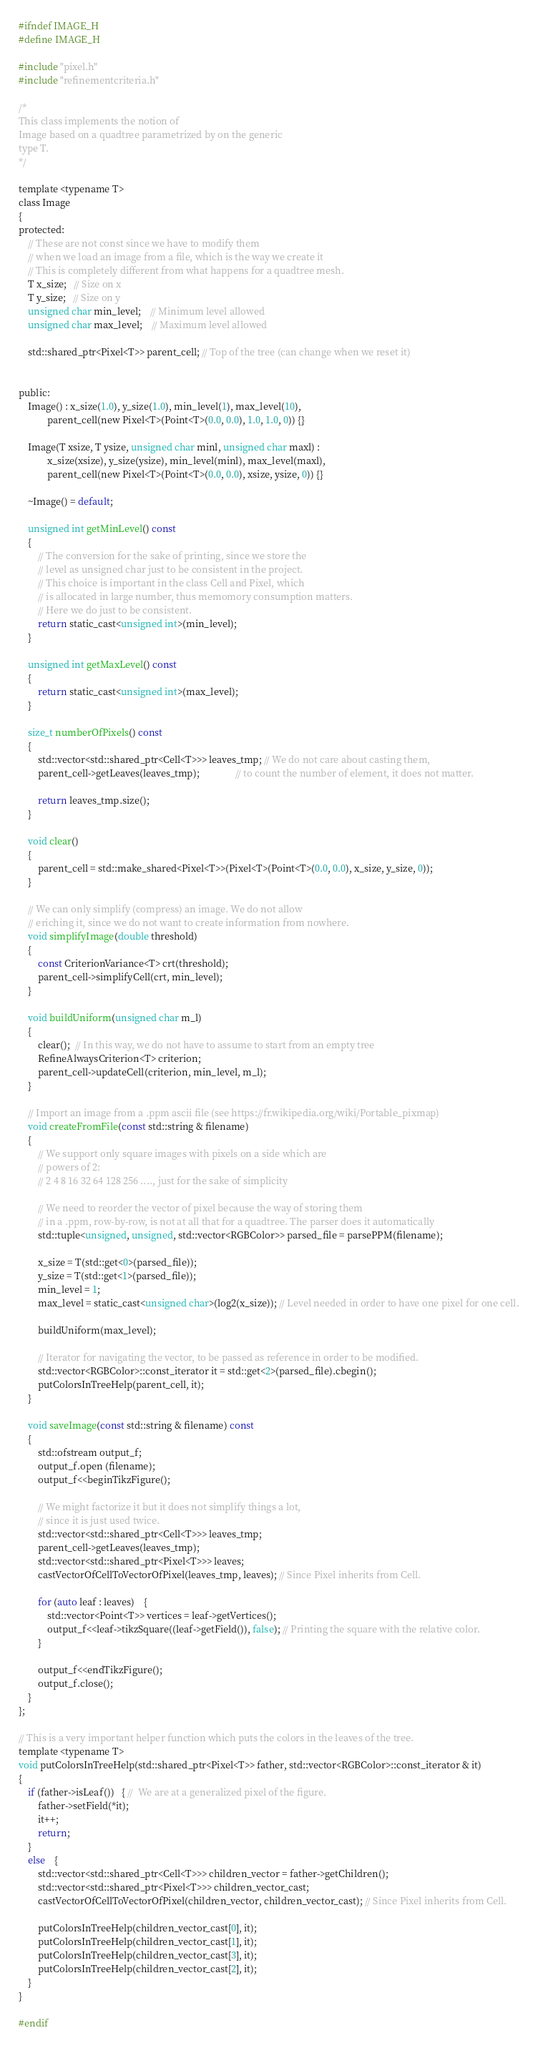Convert code to text. <code><loc_0><loc_0><loc_500><loc_500><_C_>#ifndef IMAGE_H
#define IMAGE_H

#include "pixel.h"
#include "refinementcriteria.h"

/*
This class implements the notion of 
Image based on a quadtree parametrized by on the generic 
type T.
*/

template <typename T>
class Image
{
protected:
    // These are not const since we have to modify them
    // when we load an image from a file, which is the way we create it
    // This is completely different from what happens for a quadtree mesh.
    T x_size;   // Size on x
    T y_size;   // Size on y
    unsigned char min_level;    // Minimum level allowed  
    unsigned char max_level;    // Maximum level allowed
    
    std::shared_ptr<Pixel<T>> parent_cell; // Top of the tree (can change when we reset it)


public:
    Image() : x_size(1.0), y_size(1.0), min_level(1), max_level(10), 
            parent_cell(new Pixel<T>(Point<T>(0.0, 0.0), 1.0, 1.0, 0)) {}

    Image(T xsize, T ysize, unsigned char minl, unsigned char maxl) : 
            x_size(xsize), y_size(ysize), min_level(minl), max_level(maxl), 
            parent_cell(new Pixel<T>(Point<T>(0.0, 0.0), xsize, ysize, 0)) {}

    ~Image() = default;

    unsigned int getMinLevel() const
    {
        // The conversion for the sake of printing, since we store the
        // level as unsigned char just to be consistent in the project.
        // This choice is important in the class Cell and Pixel, which
        // is allocated in large number, thus memomory consumption matters.
        // Here we do just to be consistent.
        return static_cast<unsigned int>(min_level);
    }

    unsigned int getMaxLevel() const
    {
        return static_cast<unsigned int>(max_level);
    }

    size_t numberOfPixels() const
    {
        std::vector<std::shared_ptr<Cell<T>>> leaves_tmp; // We do not care about casting them, 
        parent_cell->getLeaves(leaves_tmp);               // to count the number of element, it does not matter.

        return leaves_tmp.size();
    }

    void clear()
    {
        parent_cell = std::make_shared<Pixel<T>>(Pixel<T>(Point<T>(0.0, 0.0), x_size, y_size, 0));
    }

    // We can only simplify (compress) an image. We do not allow
    // eriching it, since we do not want to create information from nowhere.
    void simplifyImage(double threshold)
    {
        const CriterionVariance<T> crt(threshold);
        parent_cell->simplifyCell(crt, min_level);
    }

    void buildUniform(unsigned char m_l) 
    {
        clear();  // In this way, we do not have to assume to start from an empty tree
        RefineAlwaysCriterion<T> criterion;
        parent_cell->updateCell(criterion, min_level, m_l);
    }

    // Import an image from a .ppm ascii file (see https://fr.wikipedia.org/wiki/Portable_pixmap)
    void createFromFile(const std::string & filename)
    {
        // We support only square images with pixels on a side which are
        // powers of 2:
        // 2 4 8 16 32 64 128 256 ...., just for the sake of simplicity

        // We need to reorder the vector of pixel because the way of storing them
        // in a .ppm, row-by-row, is not at all that for a quadtree. The parser does it automatically
        std::tuple<unsigned, unsigned, std::vector<RGBColor>> parsed_file = parsePPM(filename);

        x_size = T(std::get<0>(parsed_file)); 
        y_size = T(std::get<1>(parsed_file)); 
        min_level = 1;
        max_level = static_cast<unsigned char>(log2(x_size)); // Level needed in order to have one pixel for one cell.

        buildUniform(max_level);

        // Iterator for navigating the vector, to be passed as reference in order to be modified.
        std::vector<RGBColor>::const_iterator it = std::get<2>(parsed_file).cbegin();
        putColorsInTreeHelp(parent_cell, it);
    }

    void saveImage(const std::string & filename) const
    {
        std::ofstream output_f;
        output_f.open (filename);
        output_f<<beginTikzFigure();

        // We might factorize it but it does not simplify things a lot,
        // since it is just used twice.
        std::vector<std::shared_ptr<Cell<T>>> leaves_tmp; 
        parent_cell->getLeaves(leaves_tmp);
        std::vector<std::shared_ptr<Pixel<T>>> leaves;
        castVectorOfCellToVectorOfPixel(leaves_tmp, leaves); // Since Pixel inherits from Cell.

        for (auto leaf : leaves)    {
            std::vector<Point<T>> vertices = leaf->getVertices();
            output_f<<leaf->tikzSquare((leaf->getField()), false); // Printing the square with the relative color.
        }

        output_f<<endTikzFigure();
        output_f.close();
    }
};

// This is a very important helper function which puts the colors in the leaves of the tree.
template <typename T>
void putColorsInTreeHelp(std::shared_ptr<Pixel<T>> father, std::vector<RGBColor>::const_iterator & it)
{
    if (father->isLeaf())   { //  We are at a generalized pixel of the figure.
        father->setField(*it);
        it++;
        return;
    }
    else    {
        std::vector<std::shared_ptr<Cell<T>>> children_vector = father->getChildren();
        std::vector<std::shared_ptr<Pixel<T>>> children_vector_cast;
        castVectorOfCellToVectorOfPixel(children_vector, children_vector_cast); // Since Pixel inherits from Cell.

        putColorsInTreeHelp(children_vector_cast[0], it);
        putColorsInTreeHelp(children_vector_cast[1], it);
        putColorsInTreeHelp(children_vector_cast[3], it);
        putColorsInTreeHelp(children_vector_cast[2], it);
    }
}

#endif
</code> 